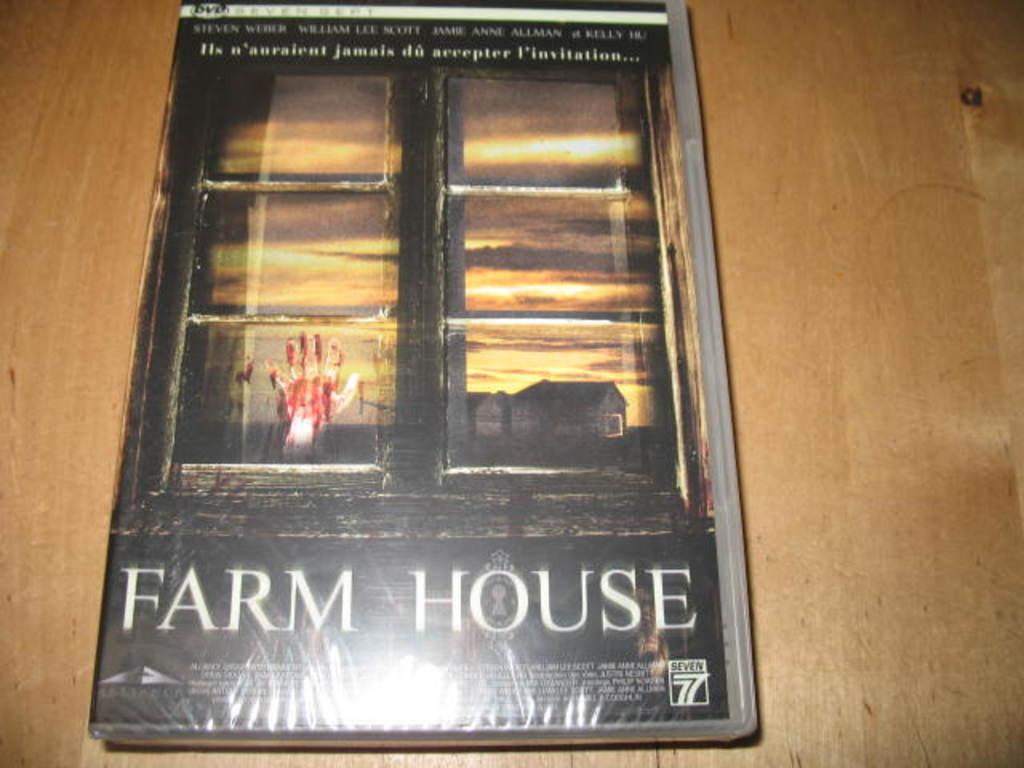<image>
Offer a succinct explanation of the picture presented. A magazine titled Farm House sits on a light oak table. 